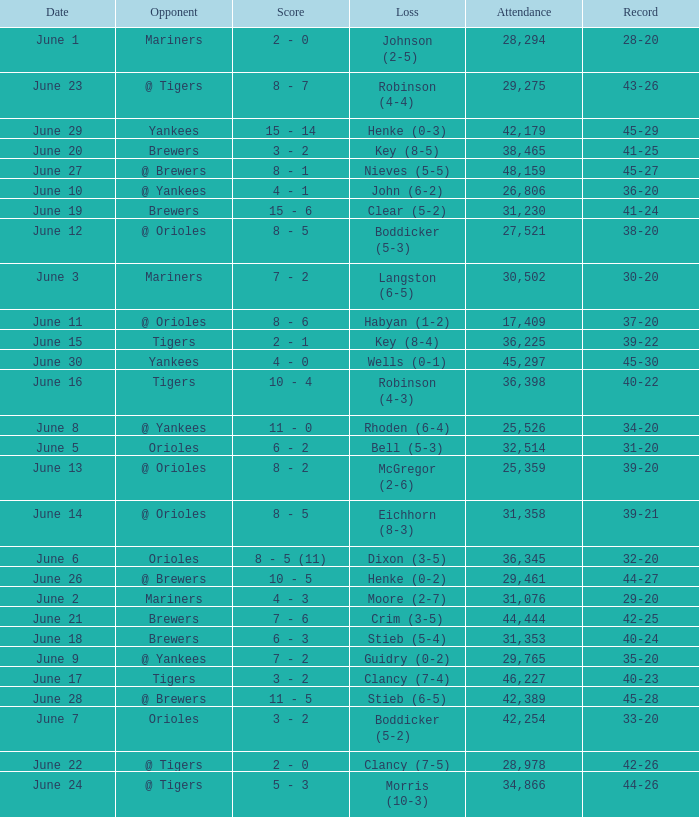What was the score when the Blue Jays had a record of 39-20? 8 - 2. 